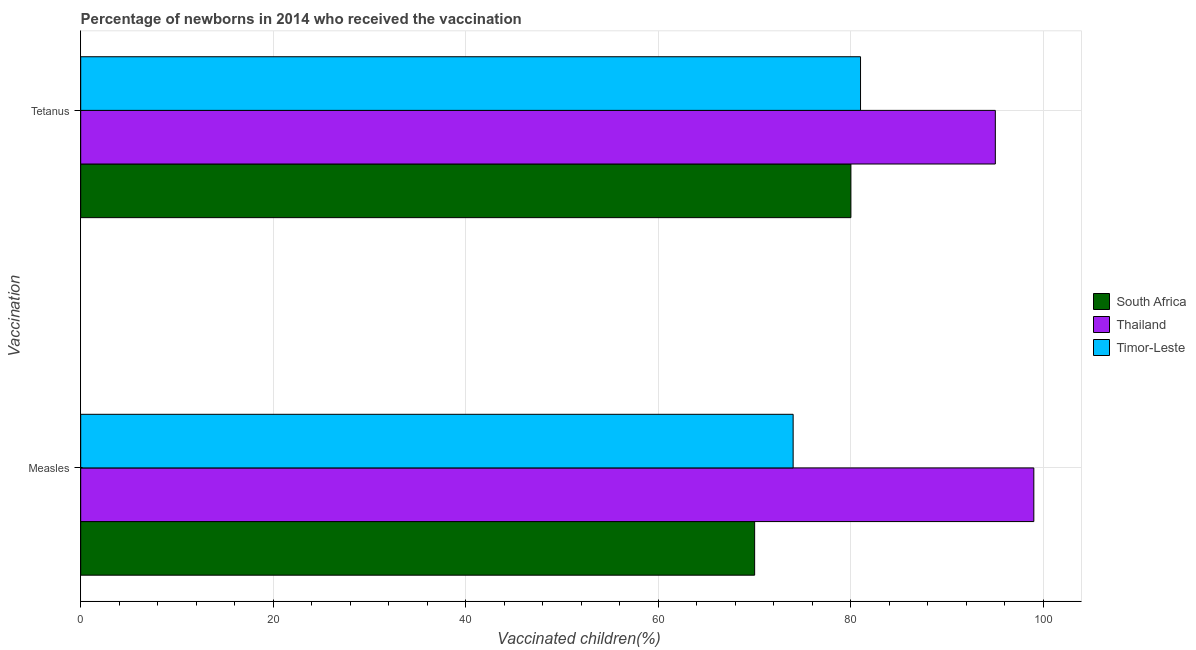How many different coloured bars are there?
Offer a very short reply. 3. How many groups of bars are there?
Offer a terse response. 2. Are the number of bars on each tick of the Y-axis equal?
Provide a short and direct response. Yes. How many bars are there on the 2nd tick from the bottom?
Offer a very short reply. 3. What is the label of the 1st group of bars from the top?
Keep it short and to the point. Tetanus. What is the percentage of newborns who received vaccination for measles in South Africa?
Your answer should be compact. 70. Across all countries, what is the maximum percentage of newborns who received vaccination for tetanus?
Give a very brief answer. 95. Across all countries, what is the minimum percentage of newborns who received vaccination for tetanus?
Provide a short and direct response. 80. In which country was the percentage of newborns who received vaccination for tetanus maximum?
Provide a succinct answer. Thailand. In which country was the percentage of newborns who received vaccination for tetanus minimum?
Your response must be concise. South Africa. What is the total percentage of newborns who received vaccination for tetanus in the graph?
Your response must be concise. 256. What is the difference between the percentage of newborns who received vaccination for measles in Timor-Leste and that in Thailand?
Your response must be concise. -25. What is the difference between the percentage of newborns who received vaccination for measles in Thailand and the percentage of newborns who received vaccination for tetanus in Timor-Leste?
Give a very brief answer. 18. What is the average percentage of newborns who received vaccination for measles per country?
Provide a succinct answer. 81. What is the difference between the percentage of newborns who received vaccination for tetanus and percentage of newborns who received vaccination for measles in South Africa?
Your response must be concise. 10. What is the ratio of the percentage of newborns who received vaccination for measles in Timor-Leste to that in Thailand?
Give a very brief answer. 0.75. Is the percentage of newborns who received vaccination for tetanus in Timor-Leste less than that in South Africa?
Make the answer very short. No. In how many countries, is the percentage of newborns who received vaccination for measles greater than the average percentage of newborns who received vaccination for measles taken over all countries?
Provide a short and direct response. 1. What does the 2nd bar from the top in Tetanus represents?
Your response must be concise. Thailand. What does the 3rd bar from the bottom in Tetanus represents?
Offer a very short reply. Timor-Leste. How many bars are there?
Keep it short and to the point. 6. Are all the bars in the graph horizontal?
Offer a very short reply. Yes. Are the values on the major ticks of X-axis written in scientific E-notation?
Keep it short and to the point. No. Where does the legend appear in the graph?
Give a very brief answer. Center right. How many legend labels are there?
Make the answer very short. 3. What is the title of the graph?
Offer a very short reply. Percentage of newborns in 2014 who received the vaccination. What is the label or title of the X-axis?
Your answer should be compact. Vaccinated children(%)
. What is the label or title of the Y-axis?
Provide a succinct answer. Vaccination. What is the Vaccinated children(%)
 in South Africa in Measles?
Provide a succinct answer. 70. What is the Vaccinated children(%)
 of Timor-Leste in Measles?
Keep it short and to the point. 74. What is the Vaccinated children(%)
 of South Africa in Tetanus?
Your answer should be compact. 80. Across all Vaccination, what is the maximum Vaccinated children(%)
 in South Africa?
Ensure brevity in your answer.  80. Across all Vaccination, what is the maximum Vaccinated children(%)
 in Thailand?
Give a very brief answer. 99. Across all Vaccination, what is the minimum Vaccinated children(%)
 of South Africa?
Give a very brief answer. 70. Across all Vaccination, what is the minimum Vaccinated children(%)
 of Thailand?
Offer a very short reply. 95. Across all Vaccination, what is the minimum Vaccinated children(%)
 of Timor-Leste?
Provide a short and direct response. 74. What is the total Vaccinated children(%)
 of South Africa in the graph?
Keep it short and to the point. 150. What is the total Vaccinated children(%)
 of Thailand in the graph?
Provide a short and direct response. 194. What is the total Vaccinated children(%)
 of Timor-Leste in the graph?
Your response must be concise. 155. What is the difference between the Vaccinated children(%)
 in South Africa in Measles and that in Tetanus?
Ensure brevity in your answer.  -10. What is the difference between the Vaccinated children(%)
 of Timor-Leste in Measles and that in Tetanus?
Provide a succinct answer. -7. What is the difference between the Vaccinated children(%)
 of South Africa in Measles and the Vaccinated children(%)
 of Thailand in Tetanus?
Give a very brief answer. -25. What is the difference between the Vaccinated children(%)
 of South Africa in Measles and the Vaccinated children(%)
 of Timor-Leste in Tetanus?
Make the answer very short. -11. What is the difference between the Vaccinated children(%)
 of Thailand in Measles and the Vaccinated children(%)
 of Timor-Leste in Tetanus?
Offer a very short reply. 18. What is the average Vaccinated children(%)
 in South Africa per Vaccination?
Keep it short and to the point. 75. What is the average Vaccinated children(%)
 of Thailand per Vaccination?
Your answer should be compact. 97. What is the average Vaccinated children(%)
 of Timor-Leste per Vaccination?
Provide a short and direct response. 77.5. What is the difference between the Vaccinated children(%)
 of South Africa and Vaccinated children(%)
 of Timor-Leste in Measles?
Make the answer very short. -4. What is the difference between the Vaccinated children(%)
 of Thailand and Vaccinated children(%)
 of Timor-Leste in Tetanus?
Give a very brief answer. 14. What is the ratio of the Vaccinated children(%)
 of Thailand in Measles to that in Tetanus?
Offer a very short reply. 1.04. What is the ratio of the Vaccinated children(%)
 in Timor-Leste in Measles to that in Tetanus?
Keep it short and to the point. 0.91. What is the difference between the highest and the second highest Vaccinated children(%)
 of Thailand?
Give a very brief answer. 4. What is the difference between the highest and the lowest Vaccinated children(%)
 in Thailand?
Provide a succinct answer. 4. 